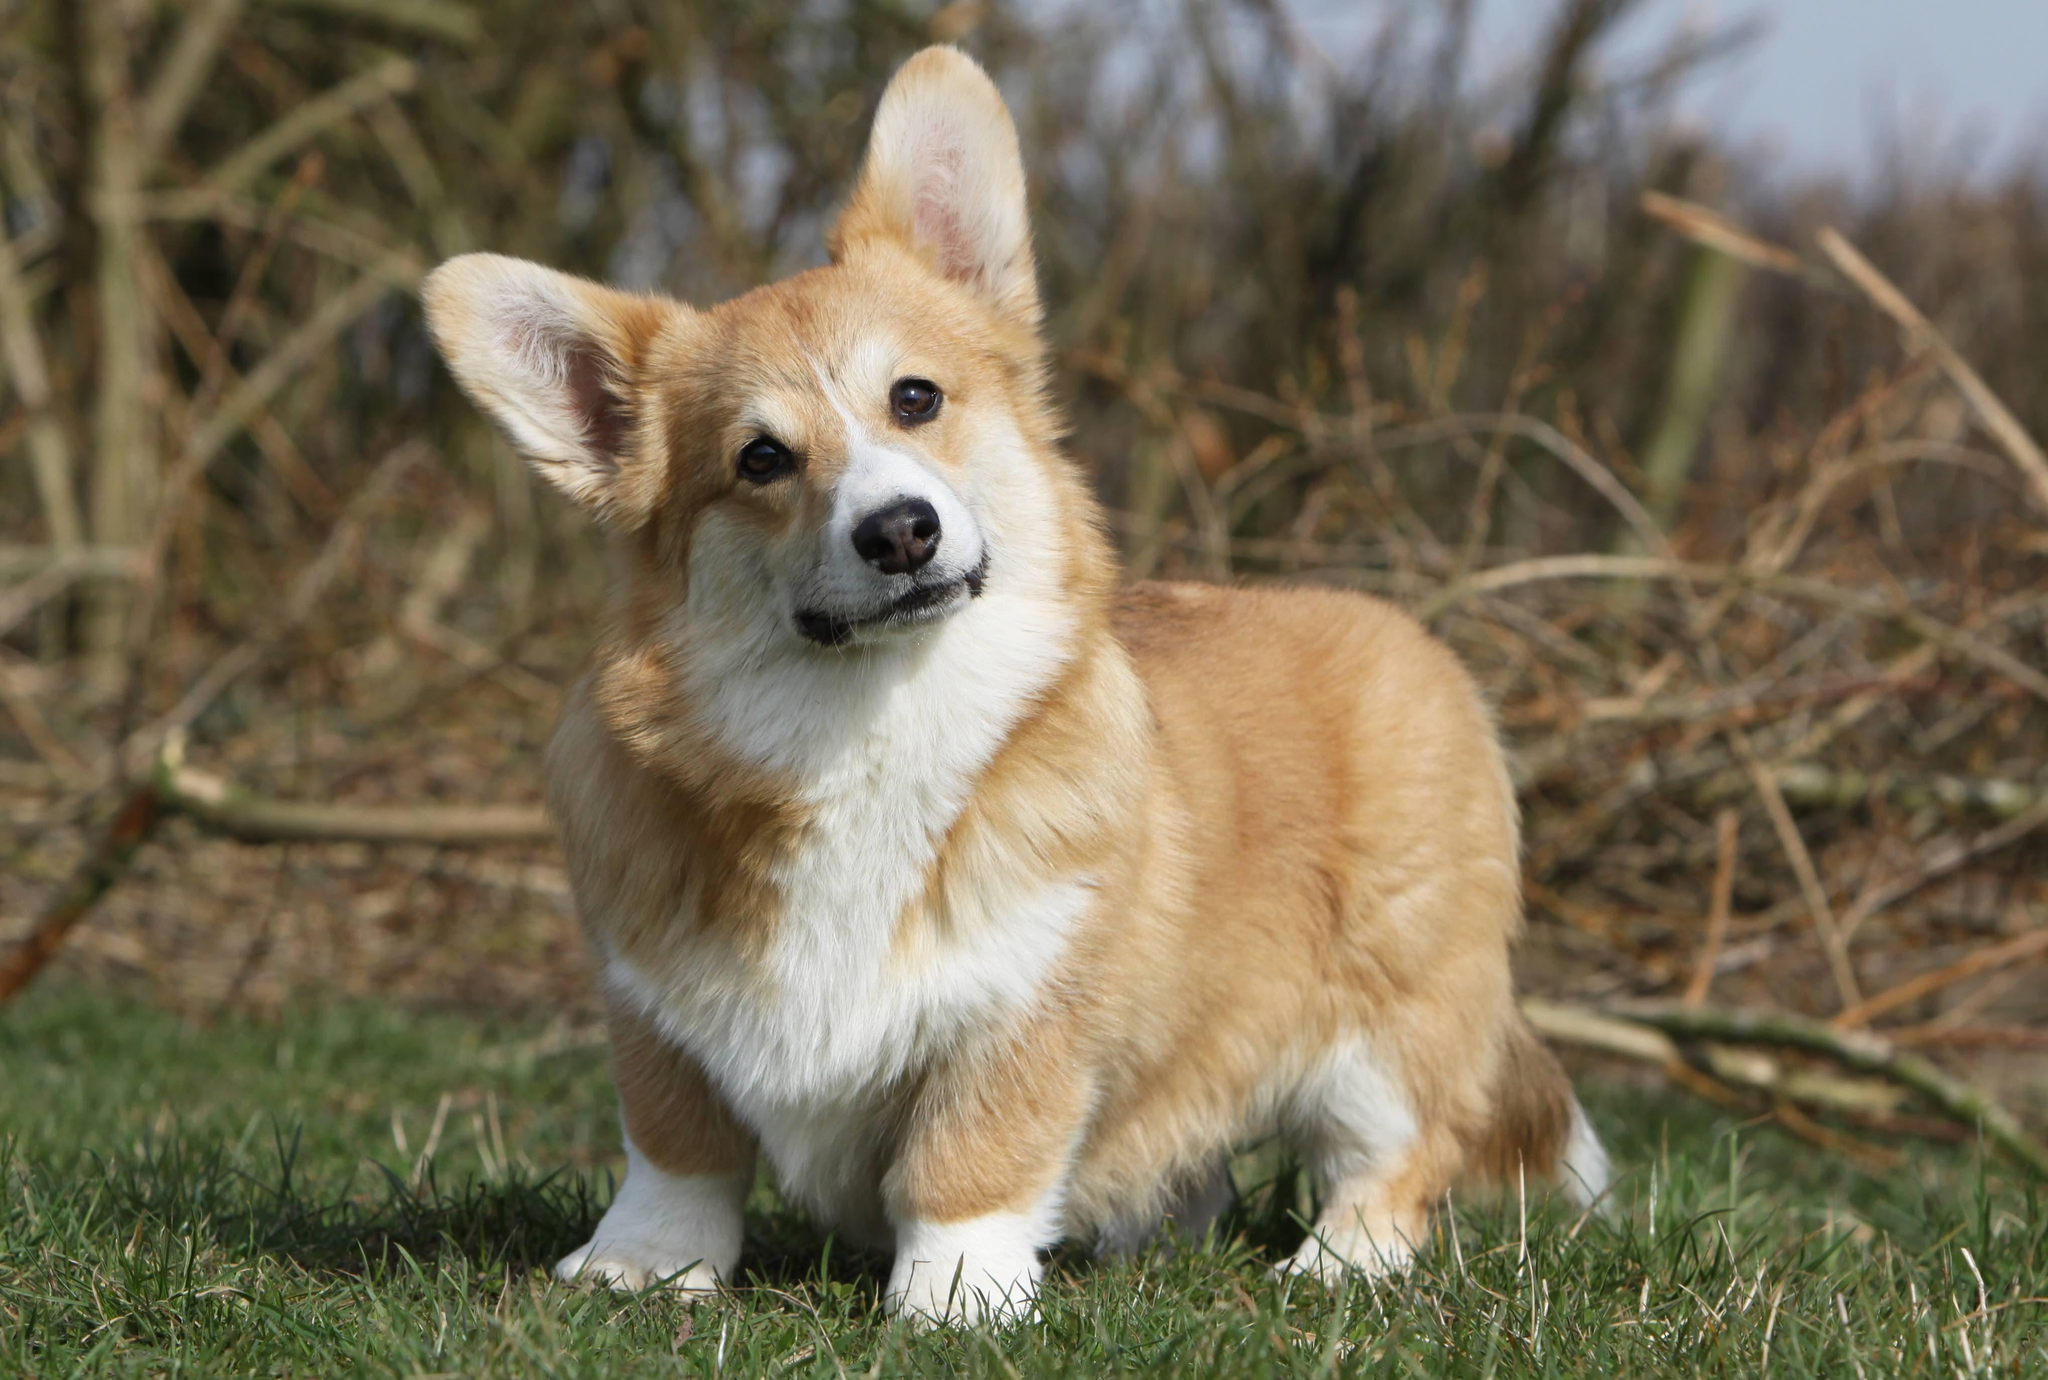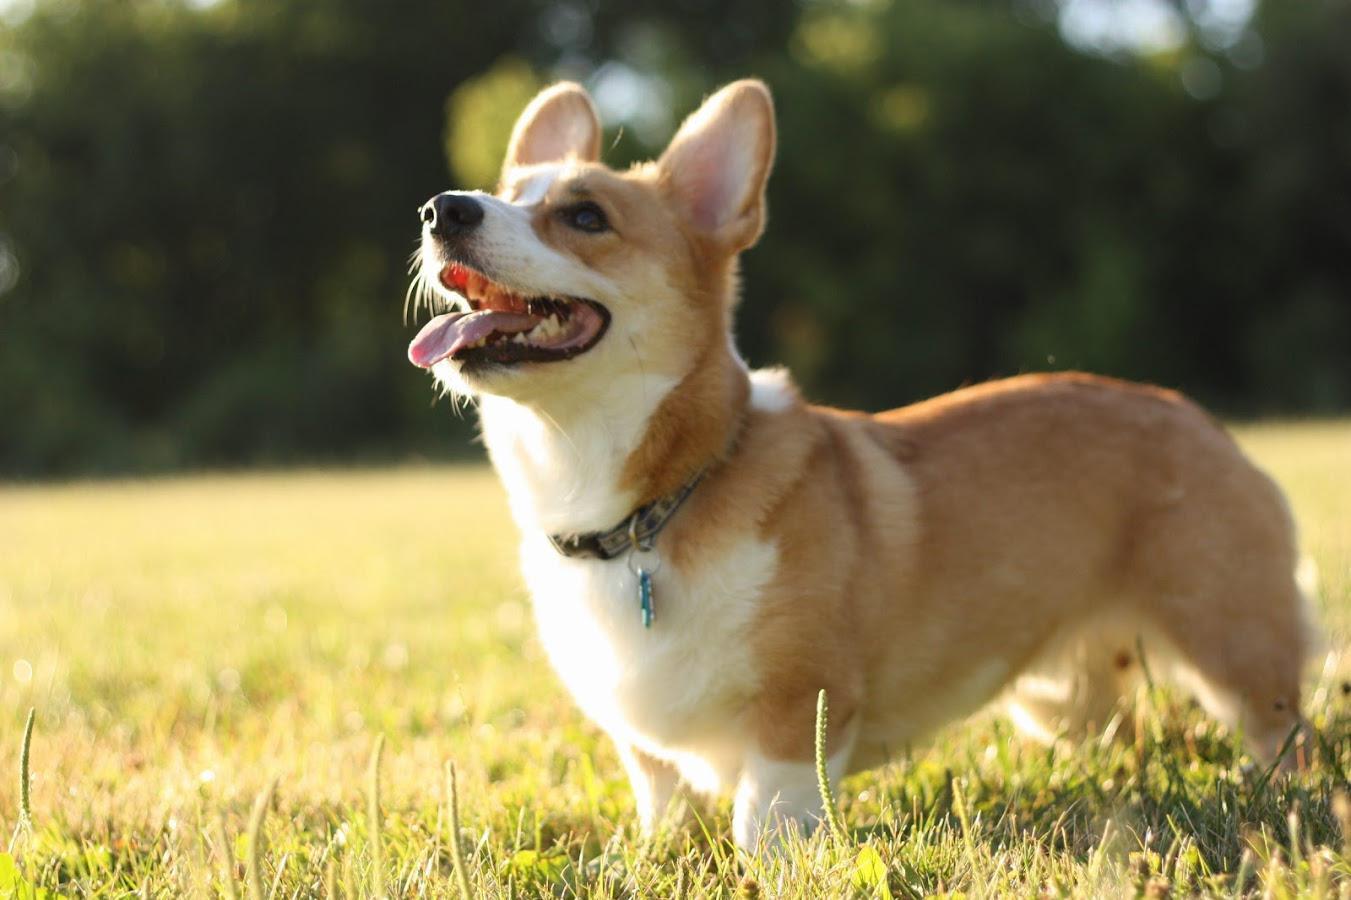The first image is the image on the left, the second image is the image on the right. Analyze the images presented: Is the assertion "A single dog is standing in the grass in the image on the right." valid? Answer yes or no. Yes. The first image is the image on the left, the second image is the image on the right. Assess this claim about the two images: "Each image contains one short-legged corgi, and all dogs are posed on green grass.". Correct or not? Answer yes or no. Yes. 